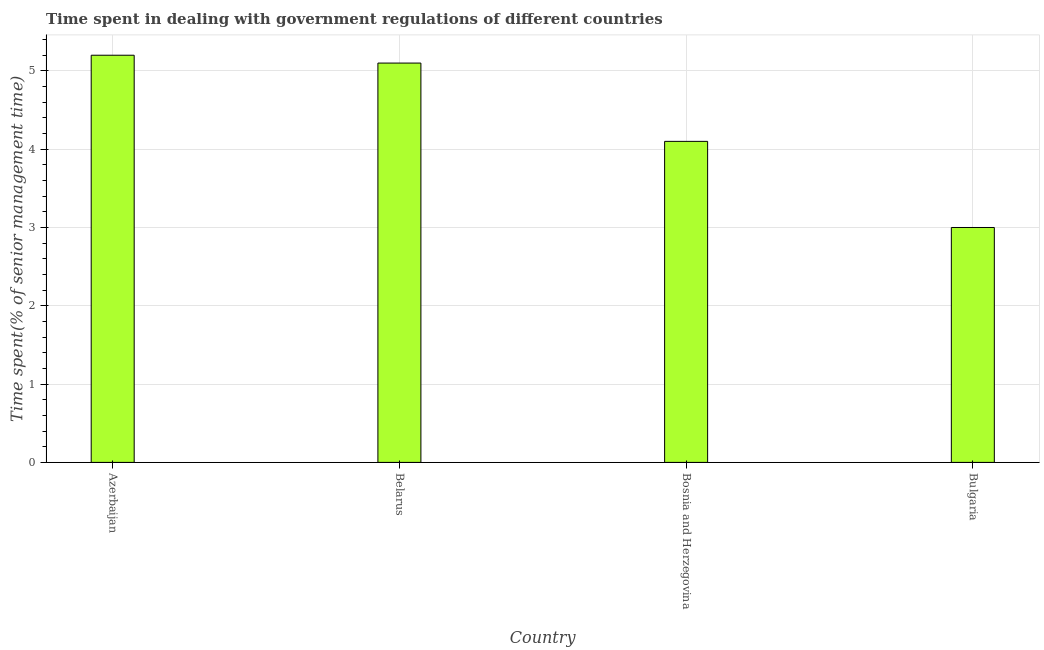Does the graph contain grids?
Make the answer very short. Yes. What is the title of the graph?
Make the answer very short. Time spent in dealing with government regulations of different countries. What is the label or title of the X-axis?
Ensure brevity in your answer.  Country. What is the label or title of the Y-axis?
Ensure brevity in your answer.  Time spent(% of senior management time). Across all countries, what is the maximum time spent in dealing with government regulations?
Offer a very short reply. 5.2. Across all countries, what is the minimum time spent in dealing with government regulations?
Make the answer very short. 3. In which country was the time spent in dealing with government regulations maximum?
Offer a very short reply. Azerbaijan. What is the average time spent in dealing with government regulations per country?
Give a very brief answer. 4.35. In how many countries, is the time spent in dealing with government regulations greater than 0.6 %?
Make the answer very short. 4. What is the ratio of the time spent in dealing with government regulations in Azerbaijan to that in Belarus?
Offer a terse response. 1.02. Is the time spent in dealing with government regulations in Bosnia and Herzegovina less than that in Bulgaria?
Offer a terse response. No. Is the difference between the time spent in dealing with government regulations in Azerbaijan and Bulgaria greater than the difference between any two countries?
Give a very brief answer. Yes. Are all the bars in the graph horizontal?
Ensure brevity in your answer.  No. What is the difference between two consecutive major ticks on the Y-axis?
Provide a short and direct response. 1. What is the Time spent(% of senior management time) of Azerbaijan?
Your answer should be very brief. 5.2. What is the difference between the Time spent(% of senior management time) in Azerbaijan and Bosnia and Herzegovina?
Make the answer very short. 1.1. What is the difference between the Time spent(% of senior management time) in Azerbaijan and Bulgaria?
Your answer should be very brief. 2.2. What is the difference between the Time spent(% of senior management time) in Bosnia and Herzegovina and Bulgaria?
Ensure brevity in your answer.  1.1. What is the ratio of the Time spent(% of senior management time) in Azerbaijan to that in Bosnia and Herzegovina?
Your response must be concise. 1.27. What is the ratio of the Time spent(% of senior management time) in Azerbaijan to that in Bulgaria?
Ensure brevity in your answer.  1.73. What is the ratio of the Time spent(% of senior management time) in Belarus to that in Bosnia and Herzegovina?
Ensure brevity in your answer.  1.24. What is the ratio of the Time spent(% of senior management time) in Bosnia and Herzegovina to that in Bulgaria?
Keep it short and to the point. 1.37. 